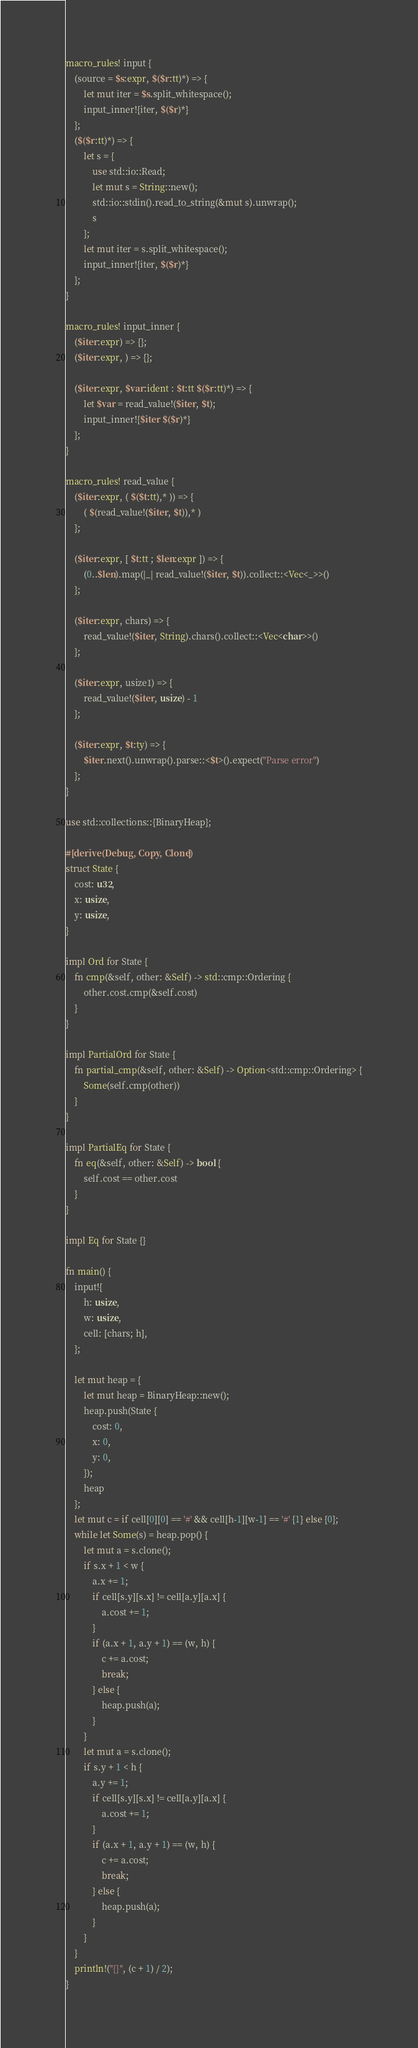Convert code to text. <code><loc_0><loc_0><loc_500><loc_500><_Rust_>macro_rules! input {
    (source = $s:expr, $($r:tt)*) => {
        let mut iter = $s.split_whitespace();
        input_inner!{iter, $($r)*}
    };
    ($($r:tt)*) => {
        let s = {
            use std::io::Read;
            let mut s = String::new();
            std::io::stdin().read_to_string(&mut s).unwrap();
            s
        };
        let mut iter = s.split_whitespace();
        input_inner!{iter, $($r)*}
    };
}

macro_rules! input_inner {
    ($iter:expr) => {};
    ($iter:expr, ) => {};

    ($iter:expr, $var:ident : $t:tt $($r:tt)*) => {
        let $var = read_value!($iter, $t);
        input_inner!{$iter $($r)*}
    };
}

macro_rules! read_value {
    ($iter:expr, ( $($t:tt),* )) => {
        ( $(read_value!($iter, $t)),* )
    };

    ($iter:expr, [ $t:tt ; $len:expr ]) => {
        (0..$len).map(|_| read_value!($iter, $t)).collect::<Vec<_>>()
    };

    ($iter:expr, chars) => {
        read_value!($iter, String).chars().collect::<Vec<char>>()
    };

    ($iter:expr, usize1) => {
        read_value!($iter, usize) - 1
    };

    ($iter:expr, $t:ty) => {
        $iter.next().unwrap().parse::<$t>().expect("Parse error")
    };
}

use std::collections::{BinaryHeap};

#[derive(Debug, Copy, Clone)]
struct State {
    cost: u32,
    x: usize,
    y: usize,
}

impl Ord for State {
    fn cmp(&self, other: &Self) -> std::cmp::Ordering {
        other.cost.cmp(&self.cost)
    }
}

impl PartialOrd for State {
    fn partial_cmp(&self, other: &Self) -> Option<std::cmp::Ordering> {
        Some(self.cmp(other))
    }
}

impl PartialEq for State {
    fn eq(&self, other: &Self) -> bool {
        self.cost == other.cost
    }
}

impl Eq for State {}

fn main() {
    input!{
        h: usize,
        w: usize,
        cell: [chars; h],
    };

    let mut heap = {
        let mut heap = BinaryHeap::new();
        heap.push(State {
            cost: 0,
            x: 0,
            y: 0,
        });
        heap
    };
    let mut c = if cell[0][0] == '#' && cell[h-1][w-1] == '#' {1} else {0};
    while let Some(s) = heap.pop() {
        let mut a = s.clone();
        if s.x + 1 < w {
            a.x += 1;
            if cell[s.y][s.x] != cell[a.y][a.x] {
                a.cost += 1;
            }
            if (a.x + 1, a.y + 1) == (w, h) {
                c += a.cost;
                break;
            } else {
                heap.push(a);
            }
        }
        let mut a = s.clone();
        if s.y + 1 < h {
            a.y += 1;
            if cell[s.y][s.x] != cell[a.y][a.x] {
                a.cost += 1;
            }
            if (a.x + 1, a.y + 1) == (w, h) {
                c += a.cost;
                break;
            } else {
                heap.push(a);
            }
        }
    }
    println!("{}", (c + 1) / 2);
}
</code> 